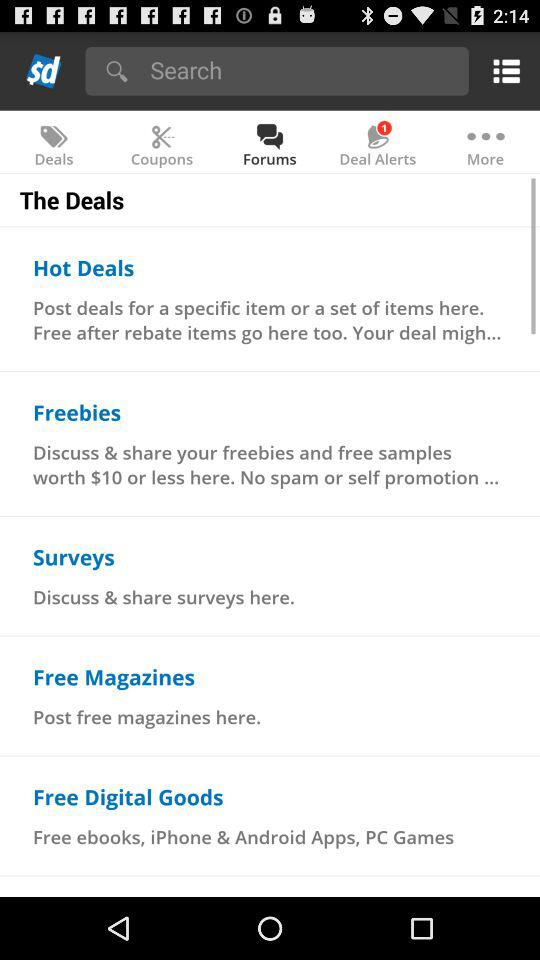What are free digital goods? The free digital goods are ebooks, iPhone & Android apps and PC games. 